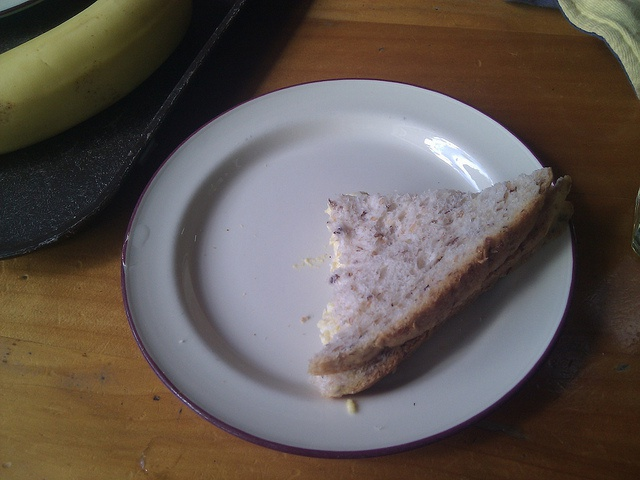Describe the objects in this image and their specific colors. I can see dining table in black, darkgray, olive, maroon, and gray tones, sandwich in gray, darkgray, and black tones, and banana in gray, black, darkgreen, and olive tones in this image. 